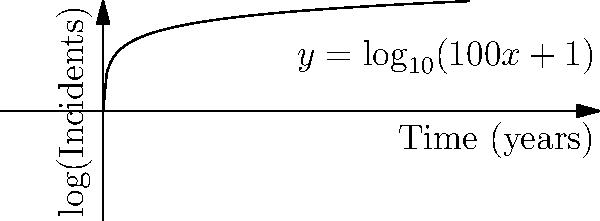Given the logarithmic function $y = \log_{10}(100x+1)$ representing the number of cybersecurity incidents over time, where $x$ is time in years and $y$ is the logarithm of the number of incidents, calculate the rate of change in incidents after 5 years. Round your answer to the nearest whole number. To find the rate of change at $x=5$, we need to follow these steps:

1) First, we need to find the derivative of the given function:
   $y = \log_{10}(100x+1)$
   $\frac{dy}{dx} = \frac{1}{\ln(10)} \cdot \frac{100}{100x+1}$

2) Now, we substitute $x=5$ into this derivative:
   $\frac{dy}{dx}|_{x=5} = \frac{1}{\ln(10)} \cdot \frac{100}{100(5)+1}$
                         $= \frac{1}{\ln(10)} \cdot \frac{100}{501}$

3) Calculate this value:
   $\frac{dy}{dx}|_{x=5} \approx 0.0868$

4) However, this is the rate of change in the logarithm of incidents. To find the actual rate of change in incidents, we need to convert this:
   Incidents $= 10^y$
   Rate of change in incidents $= \frac{d(10^y)}{dx} = 10^y \cdot \ln(10) \cdot \frac{dy}{dx}$

5) At $x=5$, $y = \log_{10}(501) \approx 2.6998$
   So, rate of change in incidents $= 10^{2.6998} \cdot \ln(10) \cdot 0.0868 \approx 501$

6) Rounding to the nearest whole number: 501
Answer: 501 incidents per year 